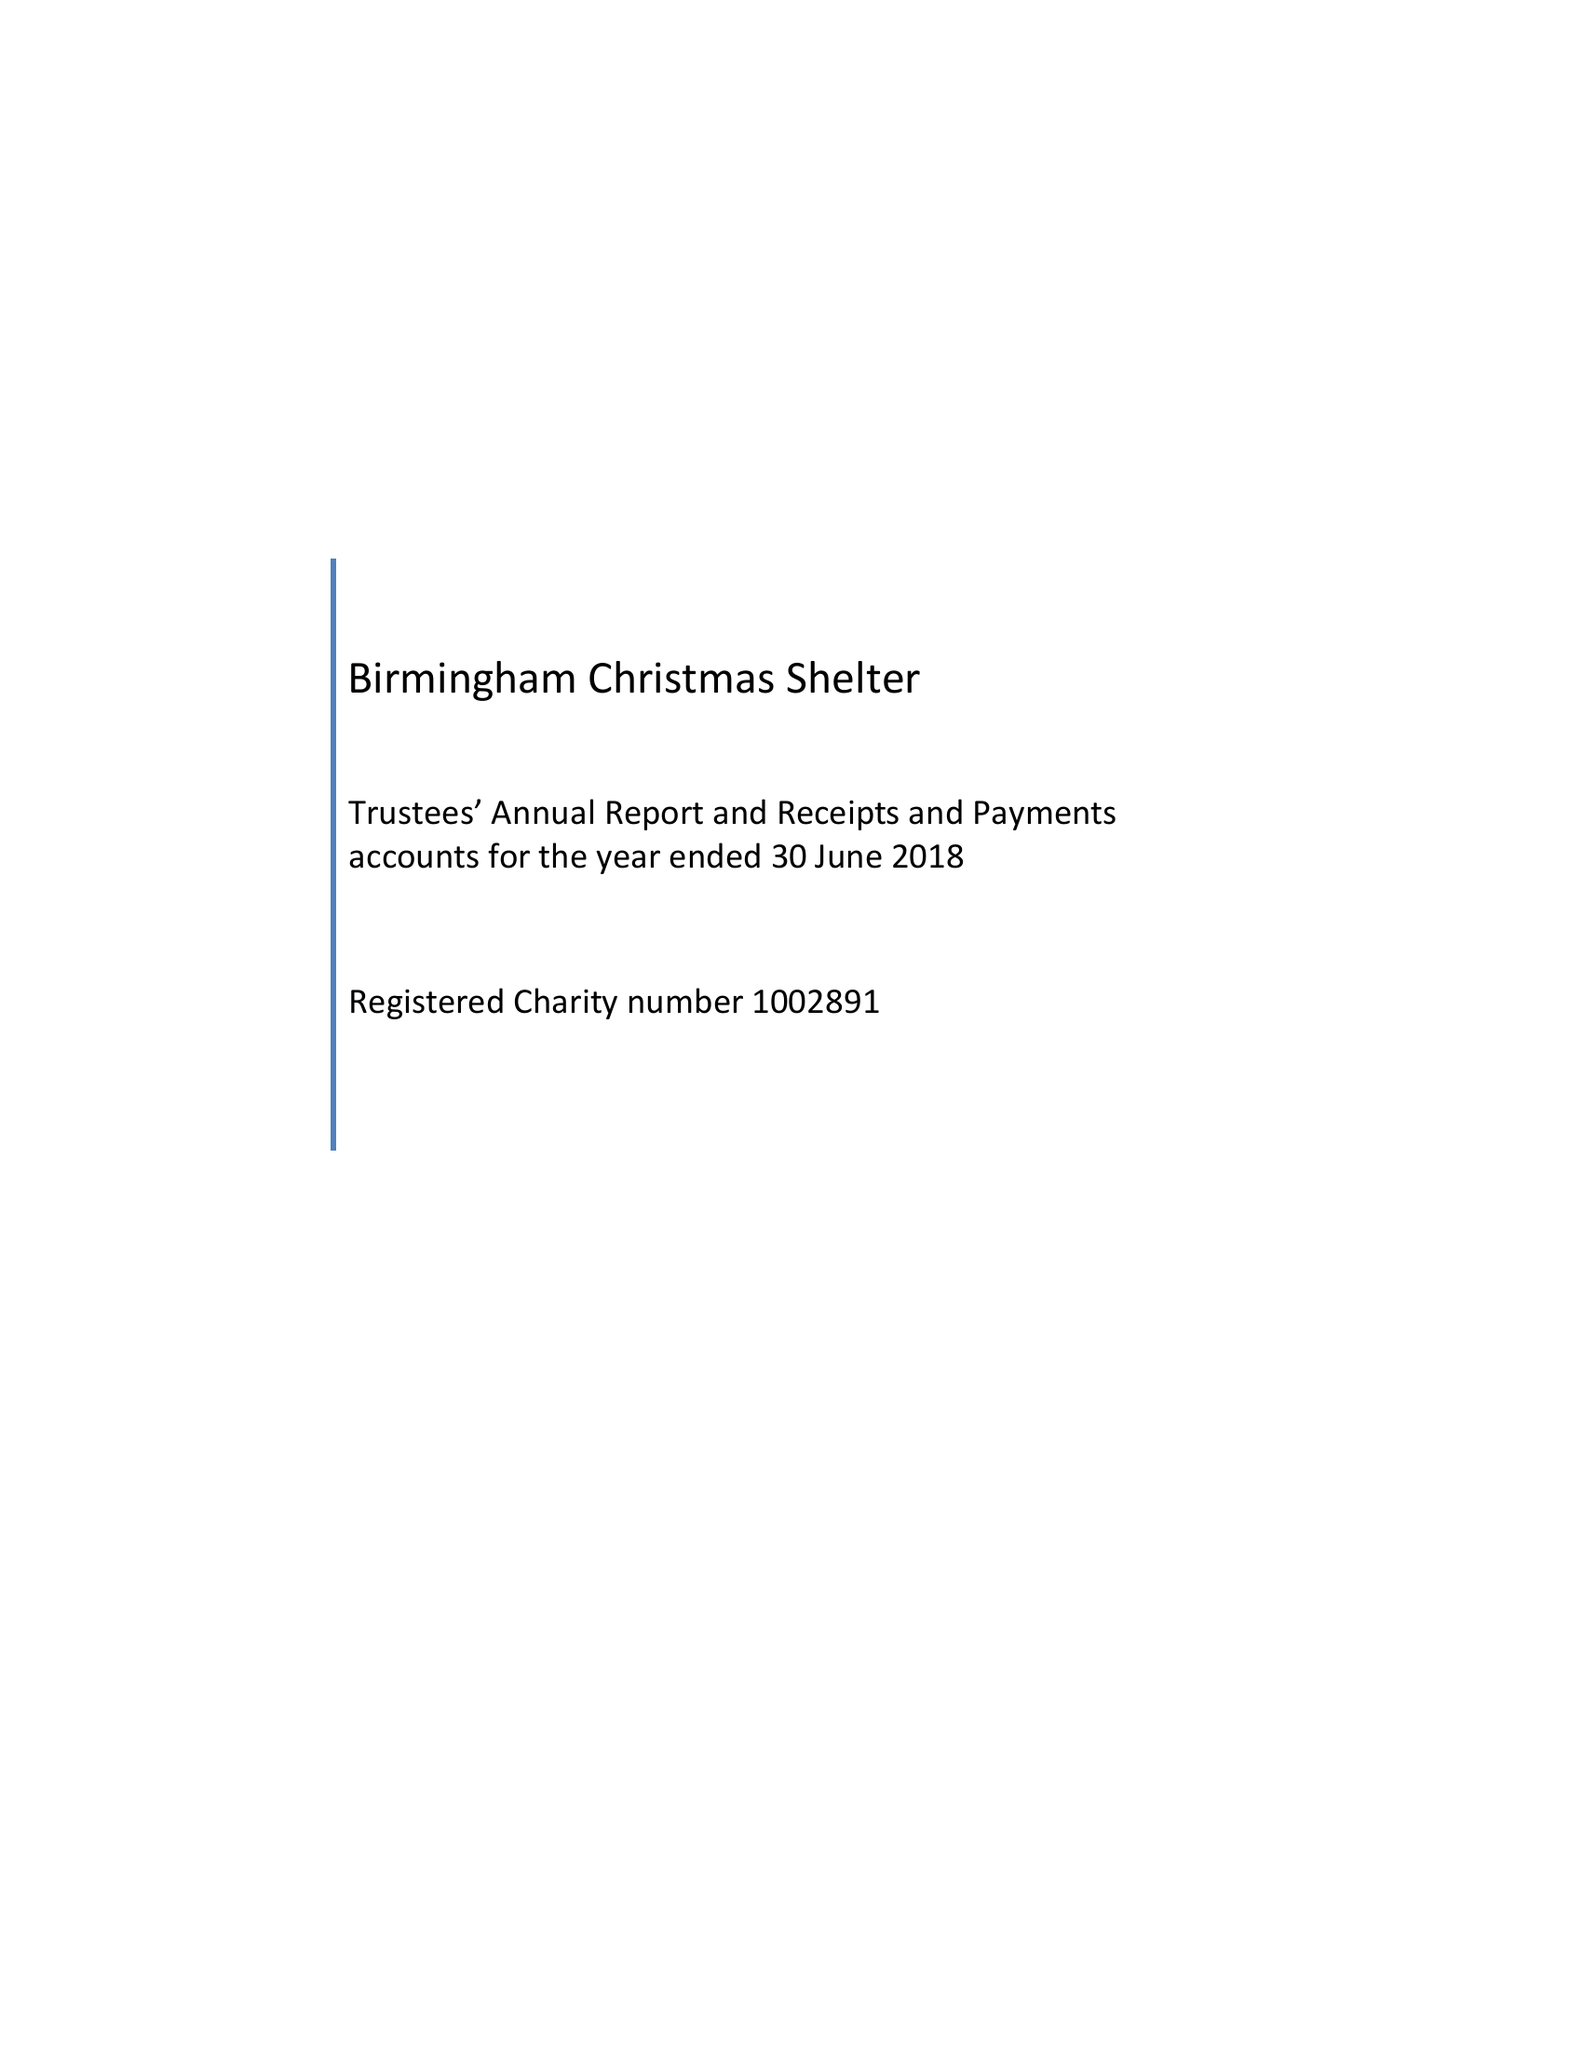What is the value for the charity_name?
Answer the question using a single word or phrase. Birmingham Christmas Shelter 